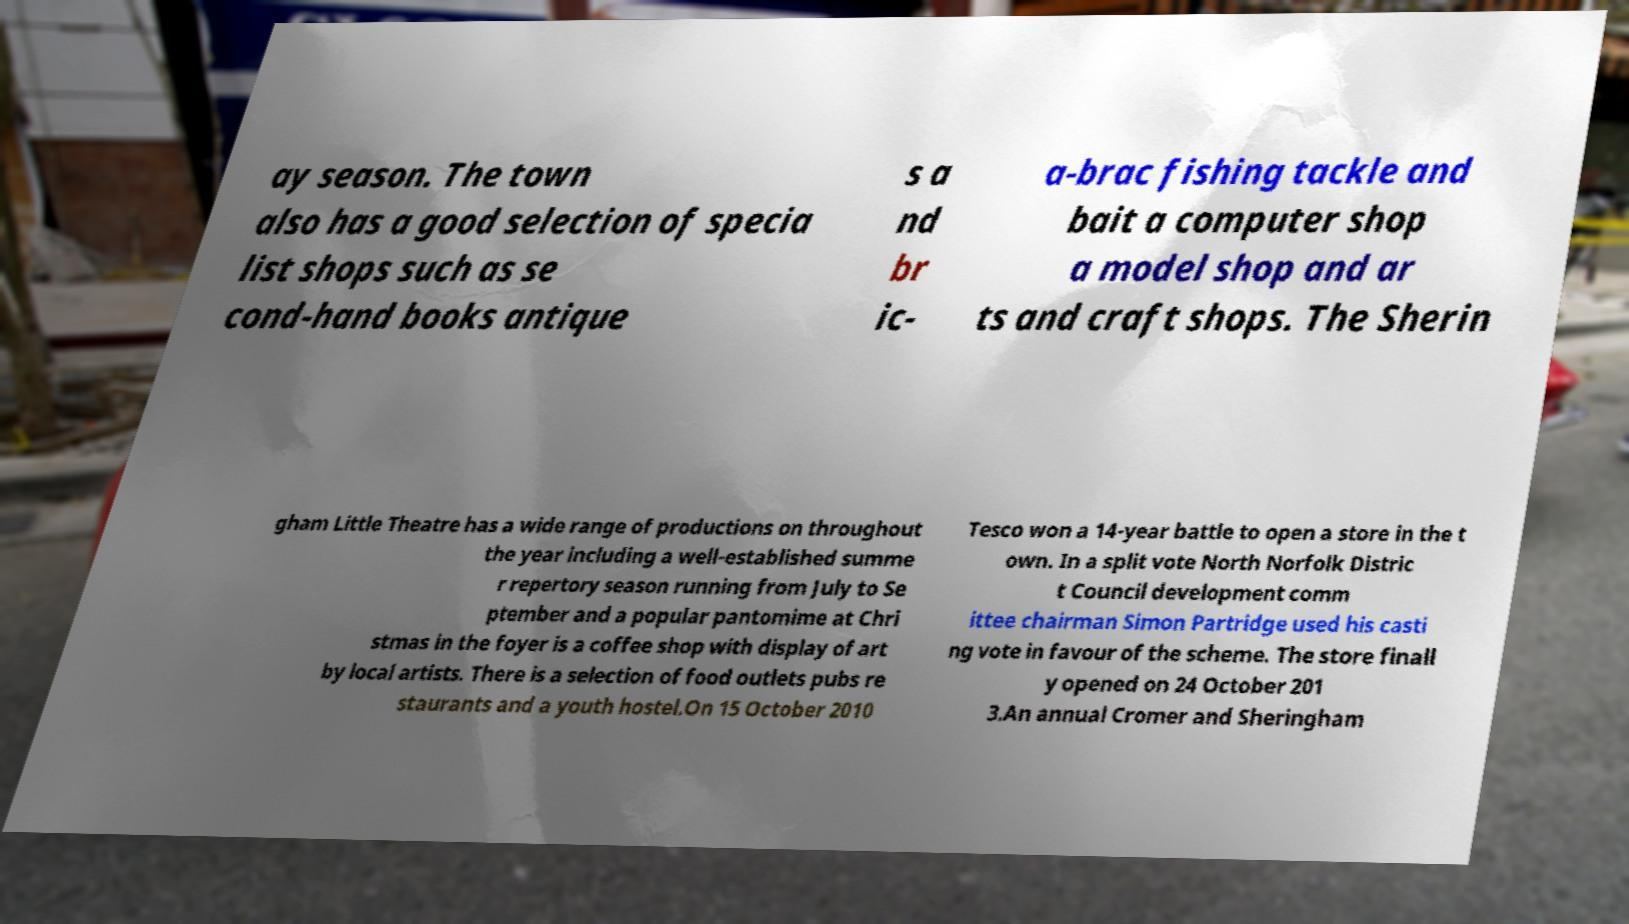Could you extract and type out the text from this image? ay season. The town also has a good selection of specia list shops such as se cond-hand books antique s a nd br ic- a-brac fishing tackle and bait a computer shop a model shop and ar ts and craft shops. The Sherin gham Little Theatre has a wide range of productions on throughout the year including a well-established summe r repertory season running from July to Se ptember and a popular pantomime at Chri stmas in the foyer is a coffee shop with display of art by local artists. There is a selection of food outlets pubs re staurants and a youth hostel.On 15 October 2010 Tesco won a 14-year battle to open a store in the t own. In a split vote North Norfolk Distric t Council development comm ittee chairman Simon Partridge used his casti ng vote in favour of the scheme. The store finall y opened on 24 October 201 3.An annual Cromer and Sheringham 